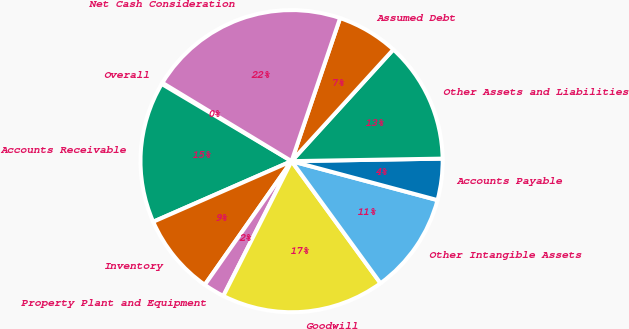<chart> <loc_0><loc_0><loc_500><loc_500><pie_chart><fcel>Overall<fcel>Accounts Receivable<fcel>Inventory<fcel>Property Plant and Equipment<fcel>Goodwill<fcel>Other Intangible Assets<fcel>Accounts Payable<fcel>Other Assets and Liabilities<fcel>Assumed Debt<fcel>Net Cash Consideration<nl><fcel>0.14%<fcel>15.11%<fcel>8.69%<fcel>2.28%<fcel>17.48%<fcel>10.83%<fcel>4.42%<fcel>12.97%<fcel>6.56%<fcel>21.53%<nl></chart> 